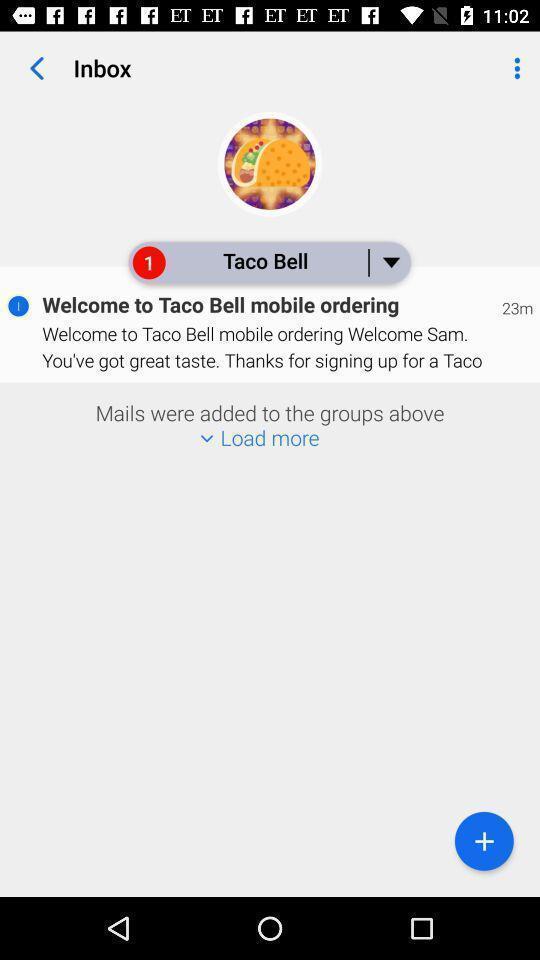Summarize the main components in this picture. Page showing inbox. 